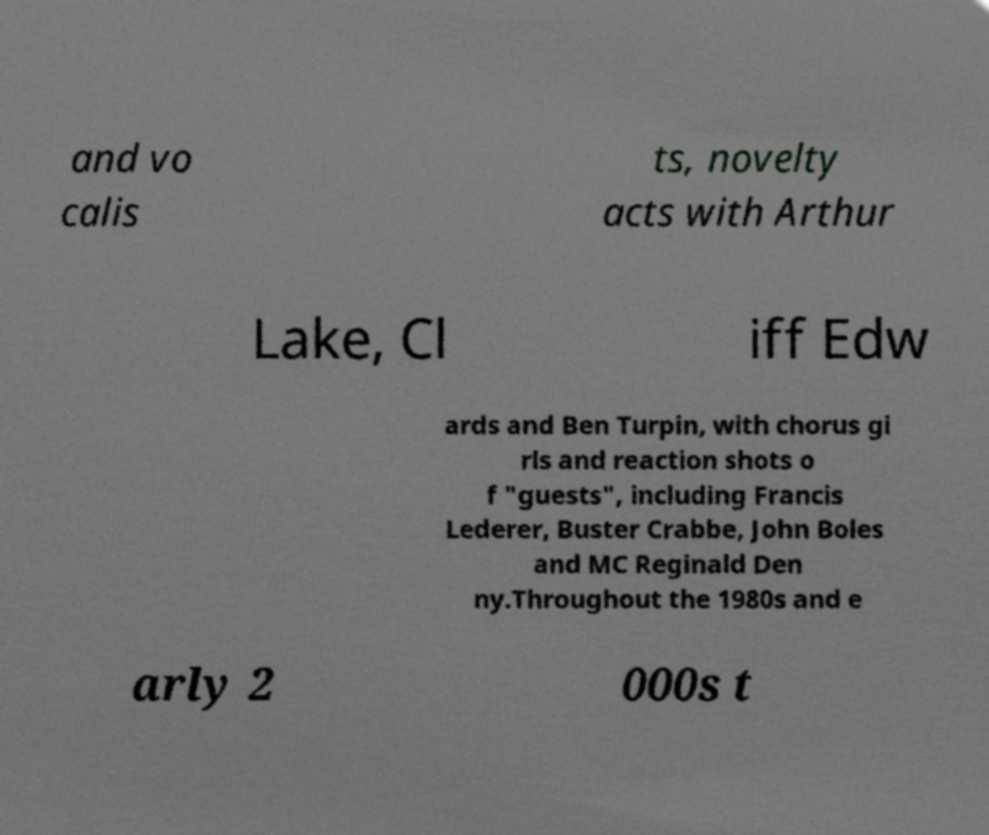For documentation purposes, I need the text within this image transcribed. Could you provide that? and vo calis ts, novelty acts with Arthur Lake, Cl iff Edw ards and Ben Turpin, with chorus gi rls and reaction shots o f "guests", including Francis Lederer, Buster Crabbe, John Boles and MC Reginald Den ny.Throughout the 1980s and e arly 2 000s t 